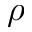<formula> <loc_0><loc_0><loc_500><loc_500>\rho</formula> 